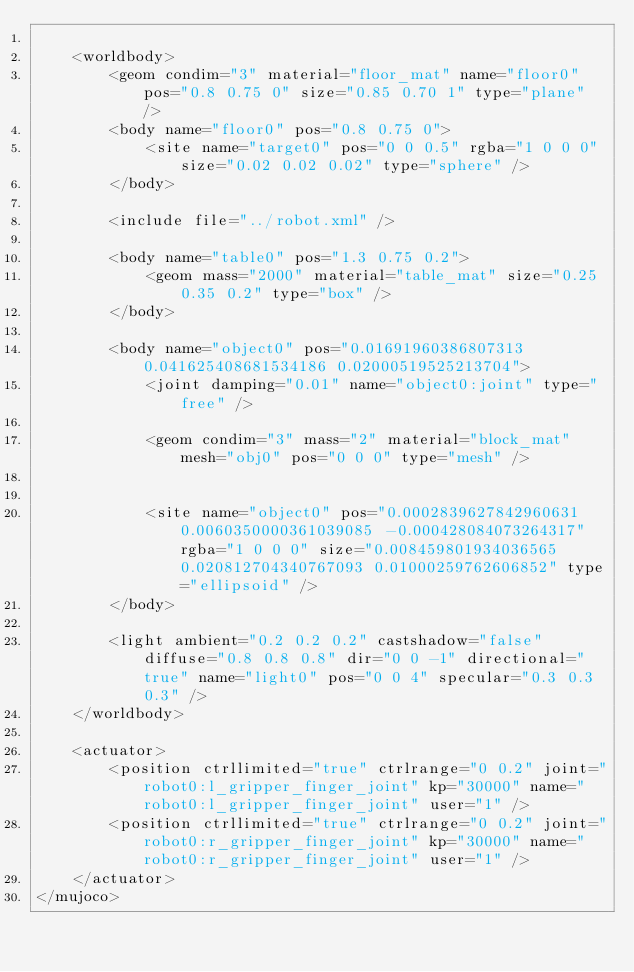<code> <loc_0><loc_0><loc_500><loc_500><_XML_>
	<worldbody>
		<geom condim="3" material="floor_mat" name="floor0" pos="0.8 0.75 0" size="0.85 0.70 1" type="plane" />
		<body name="floor0" pos="0.8 0.75 0">
			<site name="target0" pos="0 0 0.5" rgba="1 0 0 0" size="0.02 0.02 0.02" type="sphere" />
		</body>

		<include file="../robot.xml" />

		<body name="table0" pos="1.3 0.75 0.2">
			<geom mass="2000" material="table_mat" size="0.25 0.35 0.2" type="box" />
		</body>

		<body name="object0" pos="0.01691960386807313 0.041625408681534186 0.02000519525213704">
			<joint damping="0.01" name="object0:joint" type="free" />
			
			<geom condim="3" mass="2" material="block_mat" mesh="obj0" pos="0 0 0" type="mesh" />
			
			
			<site name="object0" pos="0.0002839627842960631 0.0060350000361039085 -0.000428084073264317" rgba="1 0 0 0" size="0.008459801934036565 0.020812704340767093 0.01000259762606852" type="ellipsoid" />
		</body>

		<light ambient="0.2 0.2 0.2" castshadow="false" diffuse="0.8 0.8 0.8" dir="0 0 -1" directional="true" name="light0" pos="0 0 4" specular="0.3 0.3 0.3" />
	</worldbody>

	<actuator>
		<position ctrllimited="true" ctrlrange="0 0.2" joint="robot0:l_gripper_finger_joint" kp="30000" name="robot0:l_gripper_finger_joint" user="1" />
		<position ctrllimited="true" ctrlrange="0 0.2" joint="robot0:r_gripper_finger_joint" kp="30000" name="robot0:r_gripper_finger_joint" user="1" />
	</actuator>
</mujoco></code> 